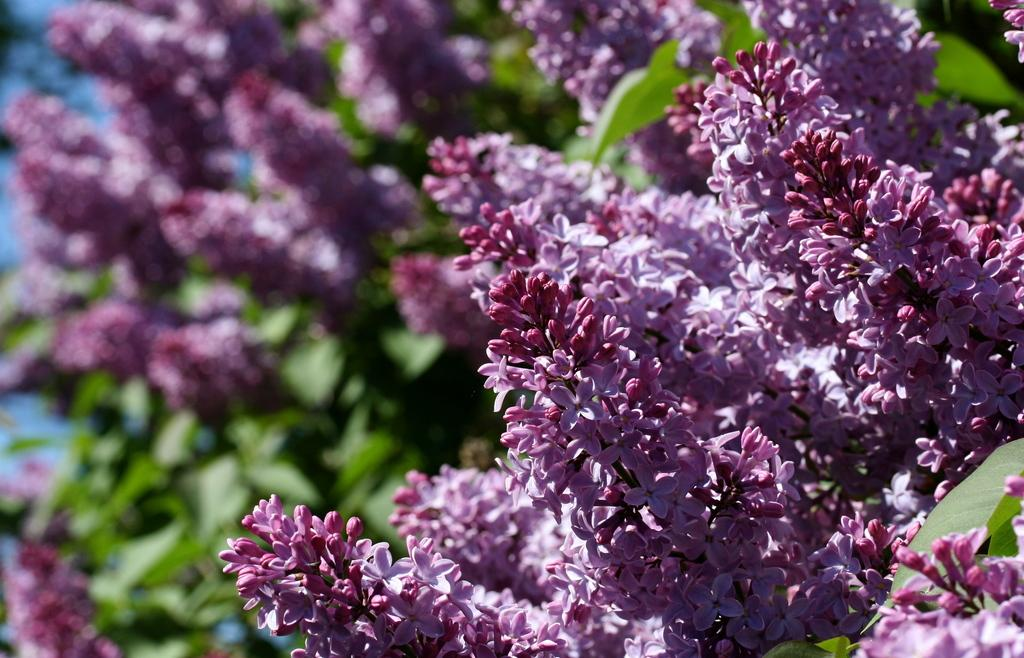What type of plants can be seen in the image? There are plants with flowers in the image. Can you describe the plants in the background of the image? The plants with flowers in the background are not clearly visible. How many rings are visible on the plants in the image? There are no rings visible on the plants in the image; it features plants with flowers. 